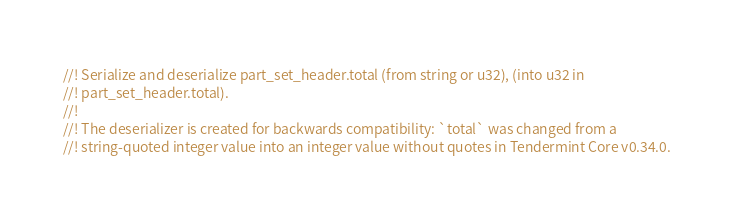<code> <loc_0><loc_0><loc_500><loc_500><_Rust_>//! Serialize and deserialize part_set_header.total (from string or u32), (into u32 in
//! part_set_header.total).
//!
//! The deserializer is created for backwards compatibility: `total` was changed from a
//! string-quoted integer value into an integer value without quotes in Tendermint Core v0.34.0.</code> 